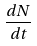<formula> <loc_0><loc_0><loc_500><loc_500>\frac { d N } { d t }</formula> 